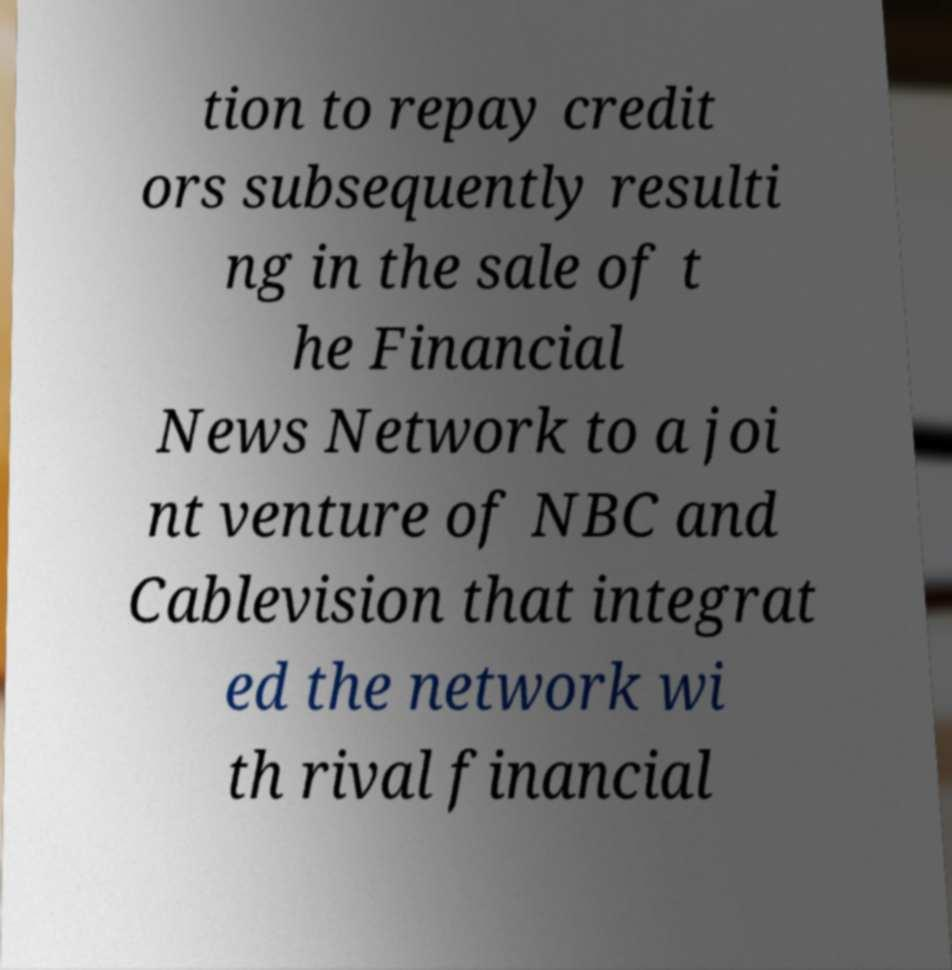Could you extract and type out the text from this image? tion to repay credit ors subsequently resulti ng in the sale of t he Financial News Network to a joi nt venture of NBC and Cablevision that integrat ed the network wi th rival financial 